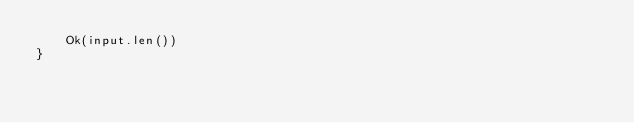Convert code to text. <code><loc_0><loc_0><loc_500><loc_500><_Rust_>    Ok(input.len())
}
</code> 